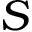<formula> <loc_0><loc_0><loc_500><loc_500>S</formula> 